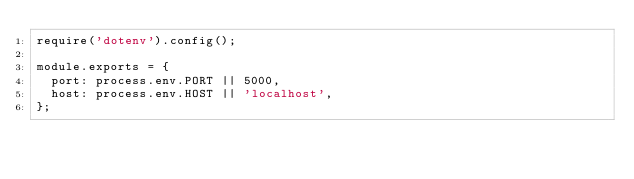<code> <loc_0><loc_0><loc_500><loc_500><_JavaScript_>require('dotenv').config();

module.exports = {
  port: process.env.PORT || 5000,
  host: process.env.HOST || 'localhost',
};
</code> 